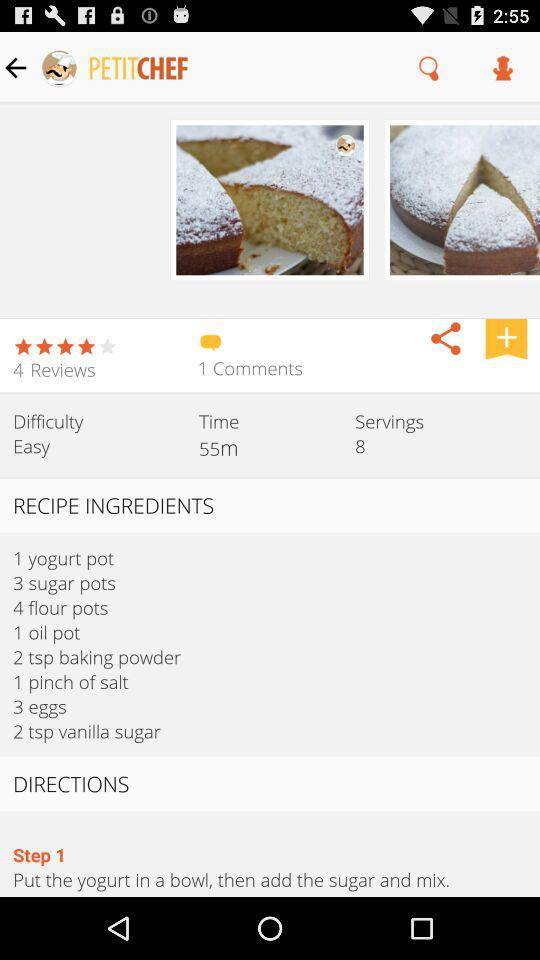How many pots of sugar are needed to make the recipe? To make the recipe, 3 pots of sugar are needed. 